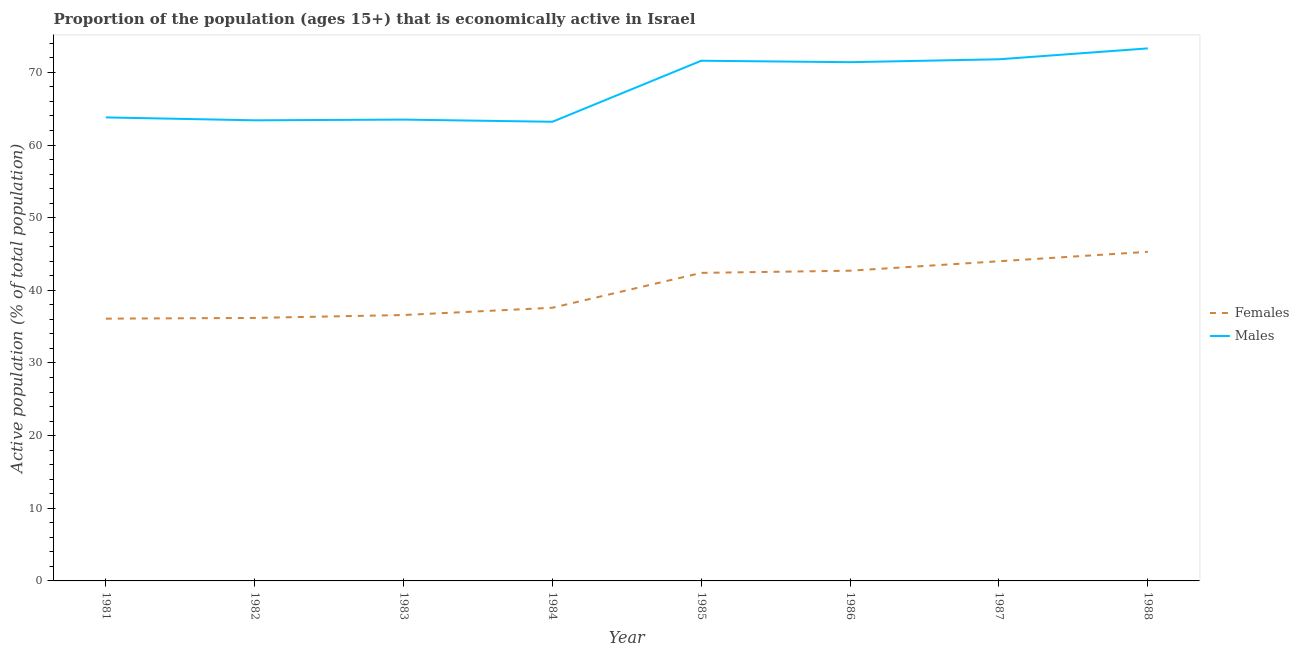Does the line corresponding to percentage of economically active male population intersect with the line corresponding to percentage of economically active female population?
Ensure brevity in your answer.  No. Is the number of lines equal to the number of legend labels?
Provide a short and direct response. Yes. What is the percentage of economically active female population in 1987?
Your response must be concise. 44. Across all years, what is the maximum percentage of economically active female population?
Your answer should be compact. 45.3. Across all years, what is the minimum percentage of economically active female population?
Your answer should be compact. 36.1. What is the total percentage of economically active female population in the graph?
Provide a succinct answer. 320.9. What is the difference between the percentage of economically active female population in 1984 and that in 1986?
Your answer should be compact. -5.1. What is the difference between the percentage of economically active male population in 1987 and the percentage of economically active female population in 1985?
Keep it short and to the point. 29.4. What is the average percentage of economically active female population per year?
Your answer should be compact. 40.11. In the year 1981, what is the difference between the percentage of economically active female population and percentage of economically active male population?
Offer a very short reply. -27.7. What is the ratio of the percentage of economically active male population in 1981 to that in 1984?
Keep it short and to the point. 1.01. What is the difference between the highest and the second highest percentage of economically active female population?
Offer a terse response. 1.3. What is the difference between the highest and the lowest percentage of economically active female population?
Provide a short and direct response. 9.2. Is the sum of the percentage of economically active female population in 1985 and 1987 greater than the maximum percentage of economically active male population across all years?
Your answer should be very brief. Yes. Does the percentage of economically active male population monotonically increase over the years?
Your answer should be compact. No. Is the percentage of economically active male population strictly less than the percentage of economically active female population over the years?
Your answer should be compact. No. How many lines are there?
Your response must be concise. 2. What is the difference between two consecutive major ticks on the Y-axis?
Your answer should be very brief. 10. Does the graph contain any zero values?
Your response must be concise. No. How many legend labels are there?
Offer a terse response. 2. How are the legend labels stacked?
Make the answer very short. Vertical. What is the title of the graph?
Make the answer very short. Proportion of the population (ages 15+) that is economically active in Israel. What is the label or title of the Y-axis?
Offer a terse response. Active population (% of total population). What is the Active population (% of total population) of Females in 1981?
Your response must be concise. 36.1. What is the Active population (% of total population) in Males in 1981?
Keep it short and to the point. 63.8. What is the Active population (% of total population) in Females in 1982?
Provide a succinct answer. 36.2. What is the Active population (% of total population) in Males in 1982?
Provide a short and direct response. 63.4. What is the Active population (% of total population) of Females in 1983?
Offer a terse response. 36.6. What is the Active population (% of total population) in Males in 1983?
Offer a terse response. 63.5. What is the Active population (% of total population) in Females in 1984?
Provide a short and direct response. 37.6. What is the Active population (% of total population) of Males in 1984?
Give a very brief answer. 63.2. What is the Active population (% of total population) in Females in 1985?
Ensure brevity in your answer.  42.4. What is the Active population (% of total population) in Males in 1985?
Provide a succinct answer. 71.6. What is the Active population (% of total population) of Females in 1986?
Offer a terse response. 42.7. What is the Active population (% of total population) in Males in 1986?
Offer a very short reply. 71.4. What is the Active population (% of total population) of Males in 1987?
Give a very brief answer. 71.8. What is the Active population (% of total population) of Females in 1988?
Keep it short and to the point. 45.3. What is the Active population (% of total population) of Males in 1988?
Your answer should be compact. 73.3. Across all years, what is the maximum Active population (% of total population) in Females?
Offer a terse response. 45.3. Across all years, what is the maximum Active population (% of total population) in Males?
Give a very brief answer. 73.3. Across all years, what is the minimum Active population (% of total population) of Females?
Offer a terse response. 36.1. Across all years, what is the minimum Active population (% of total population) in Males?
Your response must be concise. 63.2. What is the total Active population (% of total population) in Females in the graph?
Offer a very short reply. 320.9. What is the total Active population (% of total population) in Males in the graph?
Your response must be concise. 542. What is the difference between the Active population (% of total population) of Males in 1981 and that in 1982?
Your response must be concise. 0.4. What is the difference between the Active population (% of total population) in Females in 1981 and that in 1983?
Provide a short and direct response. -0.5. What is the difference between the Active population (% of total population) in Males in 1981 and that in 1983?
Provide a short and direct response. 0.3. What is the difference between the Active population (% of total population) in Females in 1981 and that in 1985?
Provide a short and direct response. -6.3. What is the difference between the Active population (% of total population) of Males in 1981 and that in 1985?
Your response must be concise. -7.8. What is the difference between the Active population (% of total population) in Males in 1981 and that in 1986?
Ensure brevity in your answer.  -7.6. What is the difference between the Active population (% of total population) in Females in 1981 and that in 1988?
Ensure brevity in your answer.  -9.2. What is the difference between the Active population (% of total population) of Females in 1982 and that in 1983?
Offer a terse response. -0.4. What is the difference between the Active population (% of total population) in Males in 1982 and that in 1983?
Provide a succinct answer. -0.1. What is the difference between the Active population (% of total population) of Females in 1982 and that in 1984?
Your answer should be very brief. -1.4. What is the difference between the Active population (% of total population) in Males in 1982 and that in 1985?
Ensure brevity in your answer.  -8.2. What is the difference between the Active population (% of total population) of Females in 1982 and that in 1988?
Make the answer very short. -9.1. What is the difference between the Active population (% of total population) of Males in 1982 and that in 1988?
Offer a terse response. -9.9. What is the difference between the Active population (% of total population) of Females in 1983 and that in 1984?
Make the answer very short. -1. What is the difference between the Active population (% of total population) of Females in 1983 and that in 1986?
Provide a succinct answer. -6.1. What is the difference between the Active population (% of total population) of Females in 1983 and that in 1987?
Make the answer very short. -7.4. What is the difference between the Active population (% of total population) of Males in 1983 and that in 1987?
Your response must be concise. -8.3. What is the difference between the Active population (% of total population) of Females in 1983 and that in 1988?
Provide a succinct answer. -8.7. What is the difference between the Active population (% of total population) in Males in 1983 and that in 1988?
Your answer should be compact. -9.8. What is the difference between the Active population (% of total population) of Females in 1984 and that in 1987?
Your answer should be compact. -6.4. What is the difference between the Active population (% of total population) of Males in 1984 and that in 1987?
Make the answer very short. -8.6. What is the difference between the Active population (% of total population) of Females in 1984 and that in 1988?
Offer a very short reply. -7.7. What is the difference between the Active population (% of total population) of Females in 1985 and that in 1986?
Provide a short and direct response. -0.3. What is the difference between the Active population (% of total population) of Males in 1985 and that in 1986?
Offer a terse response. 0.2. What is the difference between the Active population (% of total population) in Females in 1985 and that in 1988?
Keep it short and to the point. -2.9. What is the difference between the Active population (% of total population) in Males in 1985 and that in 1988?
Your answer should be very brief. -1.7. What is the difference between the Active population (% of total population) in Females in 1986 and that in 1987?
Your response must be concise. -1.3. What is the difference between the Active population (% of total population) in Females in 1986 and that in 1988?
Keep it short and to the point. -2.6. What is the difference between the Active population (% of total population) of Males in 1987 and that in 1988?
Offer a terse response. -1.5. What is the difference between the Active population (% of total population) in Females in 1981 and the Active population (% of total population) in Males in 1982?
Keep it short and to the point. -27.3. What is the difference between the Active population (% of total population) in Females in 1981 and the Active population (% of total population) in Males in 1983?
Keep it short and to the point. -27.4. What is the difference between the Active population (% of total population) in Females in 1981 and the Active population (% of total population) in Males in 1984?
Your answer should be compact. -27.1. What is the difference between the Active population (% of total population) of Females in 1981 and the Active population (% of total population) of Males in 1985?
Your answer should be compact. -35.5. What is the difference between the Active population (% of total population) in Females in 1981 and the Active population (% of total population) in Males in 1986?
Your response must be concise. -35.3. What is the difference between the Active population (% of total population) in Females in 1981 and the Active population (% of total population) in Males in 1987?
Your response must be concise. -35.7. What is the difference between the Active population (% of total population) in Females in 1981 and the Active population (% of total population) in Males in 1988?
Your response must be concise. -37.2. What is the difference between the Active population (% of total population) in Females in 1982 and the Active population (% of total population) in Males in 1983?
Provide a succinct answer. -27.3. What is the difference between the Active population (% of total population) in Females in 1982 and the Active population (% of total population) in Males in 1984?
Give a very brief answer. -27. What is the difference between the Active population (% of total population) in Females in 1982 and the Active population (% of total population) in Males in 1985?
Provide a succinct answer. -35.4. What is the difference between the Active population (% of total population) of Females in 1982 and the Active population (% of total population) of Males in 1986?
Give a very brief answer. -35.2. What is the difference between the Active population (% of total population) of Females in 1982 and the Active population (% of total population) of Males in 1987?
Your answer should be very brief. -35.6. What is the difference between the Active population (% of total population) of Females in 1982 and the Active population (% of total population) of Males in 1988?
Keep it short and to the point. -37.1. What is the difference between the Active population (% of total population) in Females in 1983 and the Active population (% of total population) in Males in 1984?
Provide a short and direct response. -26.6. What is the difference between the Active population (% of total population) in Females in 1983 and the Active population (% of total population) in Males in 1985?
Give a very brief answer. -35. What is the difference between the Active population (% of total population) of Females in 1983 and the Active population (% of total population) of Males in 1986?
Provide a short and direct response. -34.8. What is the difference between the Active population (% of total population) of Females in 1983 and the Active population (% of total population) of Males in 1987?
Ensure brevity in your answer.  -35.2. What is the difference between the Active population (% of total population) of Females in 1983 and the Active population (% of total population) of Males in 1988?
Provide a short and direct response. -36.7. What is the difference between the Active population (% of total population) in Females in 1984 and the Active population (% of total population) in Males in 1985?
Offer a terse response. -34. What is the difference between the Active population (% of total population) of Females in 1984 and the Active population (% of total population) of Males in 1986?
Give a very brief answer. -33.8. What is the difference between the Active population (% of total population) in Females in 1984 and the Active population (% of total population) in Males in 1987?
Your answer should be very brief. -34.2. What is the difference between the Active population (% of total population) of Females in 1984 and the Active population (% of total population) of Males in 1988?
Offer a terse response. -35.7. What is the difference between the Active population (% of total population) in Females in 1985 and the Active population (% of total population) in Males in 1987?
Make the answer very short. -29.4. What is the difference between the Active population (% of total population) in Females in 1985 and the Active population (% of total population) in Males in 1988?
Provide a short and direct response. -30.9. What is the difference between the Active population (% of total population) of Females in 1986 and the Active population (% of total population) of Males in 1987?
Your answer should be compact. -29.1. What is the difference between the Active population (% of total population) of Females in 1986 and the Active population (% of total population) of Males in 1988?
Your answer should be very brief. -30.6. What is the difference between the Active population (% of total population) of Females in 1987 and the Active population (% of total population) of Males in 1988?
Offer a very short reply. -29.3. What is the average Active population (% of total population) in Females per year?
Offer a very short reply. 40.11. What is the average Active population (% of total population) of Males per year?
Provide a short and direct response. 67.75. In the year 1981, what is the difference between the Active population (% of total population) in Females and Active population (% of total population) in Males?
Offer a terse response. -27.7. In the year 1982, what is the difference between the Active population (% of total population) in Females and Active population (% of total population) in Males?
Provide a succinct answer. -27.2. In the year 1983, what is the difference between the Active population (% of total population) of Females and Active population (% of total population) of Males?
Make the answer very short. -26.9. In the year 1984, what is the difference between the Active population (% of total population) in Females and Active population (% of total population) in Males?
Provide a succinct answer. -25.6. In the year 1985, what is the difference between the Active population (% of total population) in Females and Active population (% of total population) in Males?
Ensure brevity in your answer.  -29.2. In the year 1986, what is the difference between the Active population (% of total population) in Females and Active population (% of total population) in Males?
Ensure brevity in your answer.  -28.7. In the year 1987, what is the difference between the Active population (% of total population) of Females and Active population (% of total population) of Males?
Your response must be concise. -27.8. In the year 1988, what is the difference between the Active population (% of total population) of Females and Active population (% of total population) of Males?
Keep it short and to the point. -28. What is the ratio of the Active population (% of total population) in Females in 1981 to that in 1983?
Provide a short and direct response. 0.99. What is the ratio of the Active population (% of total population) of Females in 1981 to that in 1984?
Offer a terse response. 0.96. What is the ratio of the Active population (% of total population) of Males in 1981 to that in 1984?
Offer a very short reply. 1.01. What is the ratio of the Active population (% of total population) in Females in 1981 to that in 1985?
Provide a short and direct response. 0.85. What is the ratio of the Active population (% of total population) of Males in 1981 to that in 1985?
Give a very brief answer. 0.89. What is the ratio of the Active population (% of total population) in Females in 1981 to that in 1986?
Your answer should be compact. 0.85. What is the ratio of the Active population (% of total population) in Males in 1981 to that in 1986?
Offer a very short reply. 0.89. What is the ratio of the Active population (% of total population) in Females in 1981 to that in 1987?
Your answer should be very brief. 0.82. What is the ratio of the Active population (% of total population) of Males in 1981 to that in 1987?
Offer a very short reply. 0.89. What is the ratio of the Active population (% of total population) in Females in 1981 to that in 1988?
Keep it short and to the point. 0.8. What is the ratio of the Active population (% of total population) in Males in 1981 to that in 1988?
Your response must be concise. 0.87. What is the ratio of the Active population (% of total population) in Females in 1982 to that in 1983?
Offer a very short reply. 0.99. What is the ratio of the Active population (% of total population) of Females in 1982 to that in 1984?
Offer a terse response. 0.96. What is the ratio of the Active population (% of total population) in Males in 1982 to that in 1984?
Ensure brevity in your answer.  1. What is the ratio of the Active population (% of total population) of Females in 1982 to that in 1985?
Your answer should be compact. 0.85. What is the ratio of the Active population (% of total population) of Males in 1982 to that in 1985?
Your answer should be compact. 0.89. What is the ratio of the Active population (% of total population) in Females in 1982 to that in 1986?
Give a very brief answer. 0.85. What is the ratio of the Active population (% of total population) in Males in 1982 to that in 1986?
Your answer should be compact. 0.89. What is the ratio of the Active population (% of total population) in Females in 1982 to that in 1987?
Make the answer very short. 0.82. What is the ratio of the Active population (% of total population) of Males in 1982 to that in 1987?
Offer a very short reply. 0.88. What is the ratio of the Active population (% of total population) in Females in 1982 to that in 1988?
Make the answer very short. 0.8. What is the ratio of the Active population (% of total population) in Males in 1982 to that in 1988?
Keep it short and to the point. 0.86. What is the ratio of the Active population (% of total population) in Females in 1983 to that in 1984?
Your answer should be very brief. 0.97. What is the ratio of the Active population (% of total population) in Males in 1983 to that in 1984?
Ensure brevity in your answer.  1. What is the ratio of the Active population (% of total population) of Females in 1983 to that in 1985?
Your answer should be very brief. 0.86. What is the ratio of the Active population (% of total population) of Males in 1983 to that in 1985?
Make the answer very short. 0.89. What is the ratio of the Active population (% of total population) of Males in 1983 to that in 1986?
Give a very brief answer. 0.89. What is the ratio of the Active population (% of total population) of Females in 1983 to that in 1987?
Offer a very short reply. 0.83. What is the ratio of the Active population (% of total population) in Males in 1983 to that in 1987?
Provide a succinct answer. 0.88. What is the ratio of the Active population (% of total population) of Females in 1983 to that in 1988?
Make the answer very short. 0.81. What is the ratio of the Active population (% of total population) of Males in 1983 to that in 1988?
Give a very brief answer. 0.87. What is the ratio of the Active population (% of total population) of Females in 1984 to that in 1985?
Give a very brief answer. 0.89. What is the ratio of the Active population (% of total population) of Males in 1984 to that in 1985?
Provide a succinct answer. 0.88. What is the ratio of the Active population (% of total population) in Females in 1984 to that in 1986?
Offer a very short reply. 0.88. What is the ratio of the Active population (% of total population) in Males in 1984 to that in 1986?
Provide a succinct answer. 0.89. What is the ratio of the Active population (% of total population) of Females in 1984 to that in 1987?
Make the answer very short. 0.85. What is the ratio of the Active population (% of total population) in Males in 1984 to that in 1987?
Your answer should be very brief. 0.88. What is the ratio of the Active population (% of total population) in Females in 1984 to that in 1988?
Make the answer very short. 0.83. What is the ratio of the Active population (% of total population) of Males in 1984 to that in 1988?
Provide a succinct answer. 0.86. What is the ratio of the Active population (% of total population) in Males in 1985 to that in 1986?
Your answer should be very brief. 1. What is the ratio of the Active population (% of total population) of Females in 1985 to that in 1987?
Your response must be concise. 0.96. What is the ratio of the Active population (% of total population) in Females in 1985 to that in 1988?
Keep it short and to the point. 0.94. What is the ratio of the Active population (% of total population) of Males in 1985 to that in 1988?
Offer a terse response. 0.98. What is the ratio of the Active population (% of total population) of Females in 1986 to that in 1987?
Offer a terse response. 0.97. What is the ratio of the Active population (% of total population) in Females in 1986 to that in 1988?
Ensure brevity in your answer.  0.94. What is the ratio of the Active population (% of total population) in Males in 1986 to that in 1988?
Your answer should be very brief. 0.97. What is the ratio of the Active population (% of total population) of Females in 1987 to that in 1988?
Give a very brief answer. 0.97. What is the ratio of the Active population (% of total population) of Males in 1987 to that in 1988?
Your answer should be very brief. 0.98. What is the difference between the highest and the second highest Active population (% of total population) of Males?
Your answer should be compact. 1.5. 